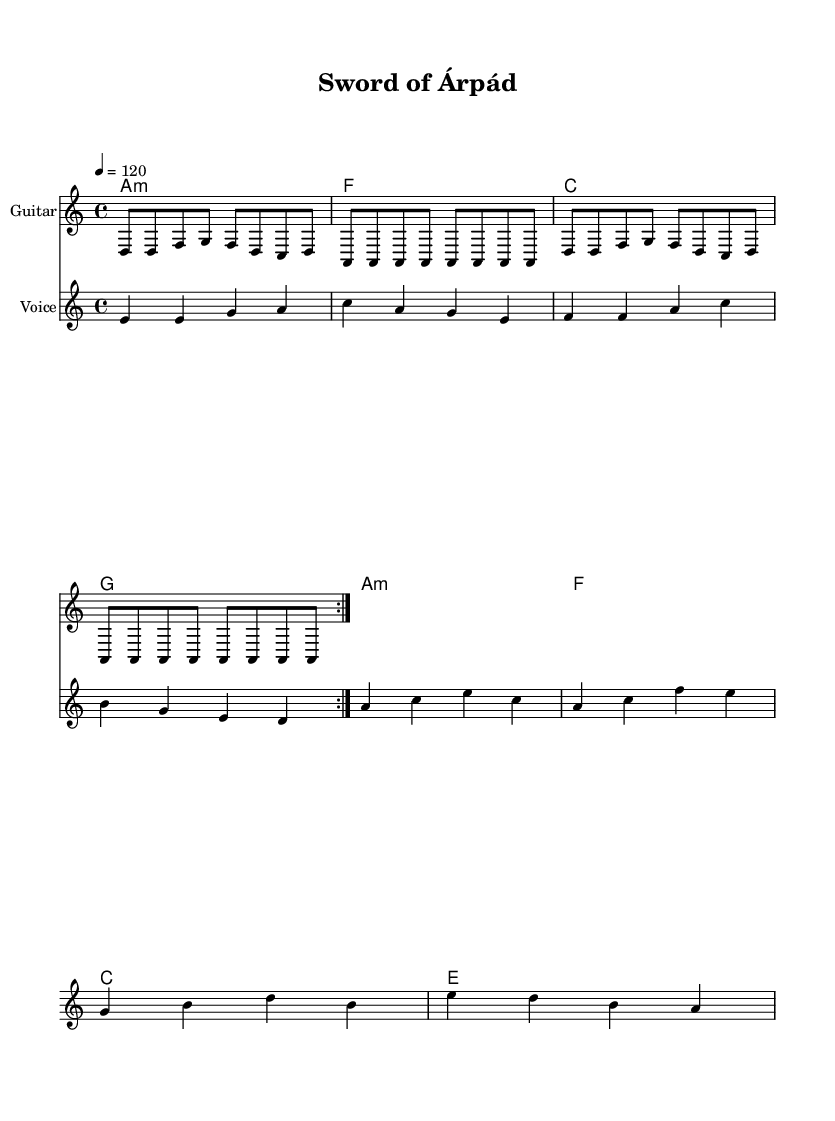What is the key signature of this music? The key signature is A minor, which has no sharps or flats. While in the sheet music, the 'A' minor chord (A minor indicates a minor key) is consistently presented in the harmonies, aligning with the absence of accidentals.
Answer: A minor What is the time signature of this music? The time signature is 4/4, as indicated at the beginning of the score. This means there are four beats in each measure, and the quarter note gets one beat. This is typical for electric blues, which commonly employs this rhythm.
Answer: 4/4 What is the tempo of this music? The tempo is indicated as 120 beats per minute (bpm), as stated in the score. This means the song is performed at a moderate pace, which is common in electric blues to allow for expressive guitar solos and vocal lines.
Answer: 120 How many times is the verse repeated? The verse is repeated twice, as indicated by the "volta" marking in the melody section. This suggests that the first verse is played, and then it is played again before moving on to additional sections.
Answer: 2 What is the title of this piece? The title of the piece is "Sword of Árpád", which is displayed in the header section of the score. This title reflects the historical inspiration behind the lyrics and the overall theme of the piece, tying into Hungarian historical artifacts.
Answer: Sword of Árpád What is the last note of the melody? The last note of the melody is A, as per the final measure in the melody section. This ending note completes the melodic line and gives a sense of resolution, which is often desired in blues compositions.
Answer: A 